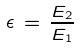Convert formula to latex. <formula><loc_0><loc_0><loc_500><loc_500>\epsilon \, = \, \frac { E _ { 2 } } { E _ { 1 } }</formula> 